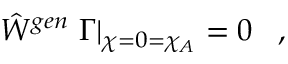Convert formula to latex. <formula><loc_0><loc_0><loc_500><loc_500>\hat { W } ^ { g e n } \Gamma \right | _ { \chi = 0 = \chi _ { A } } = 0 \, ,</formula> 